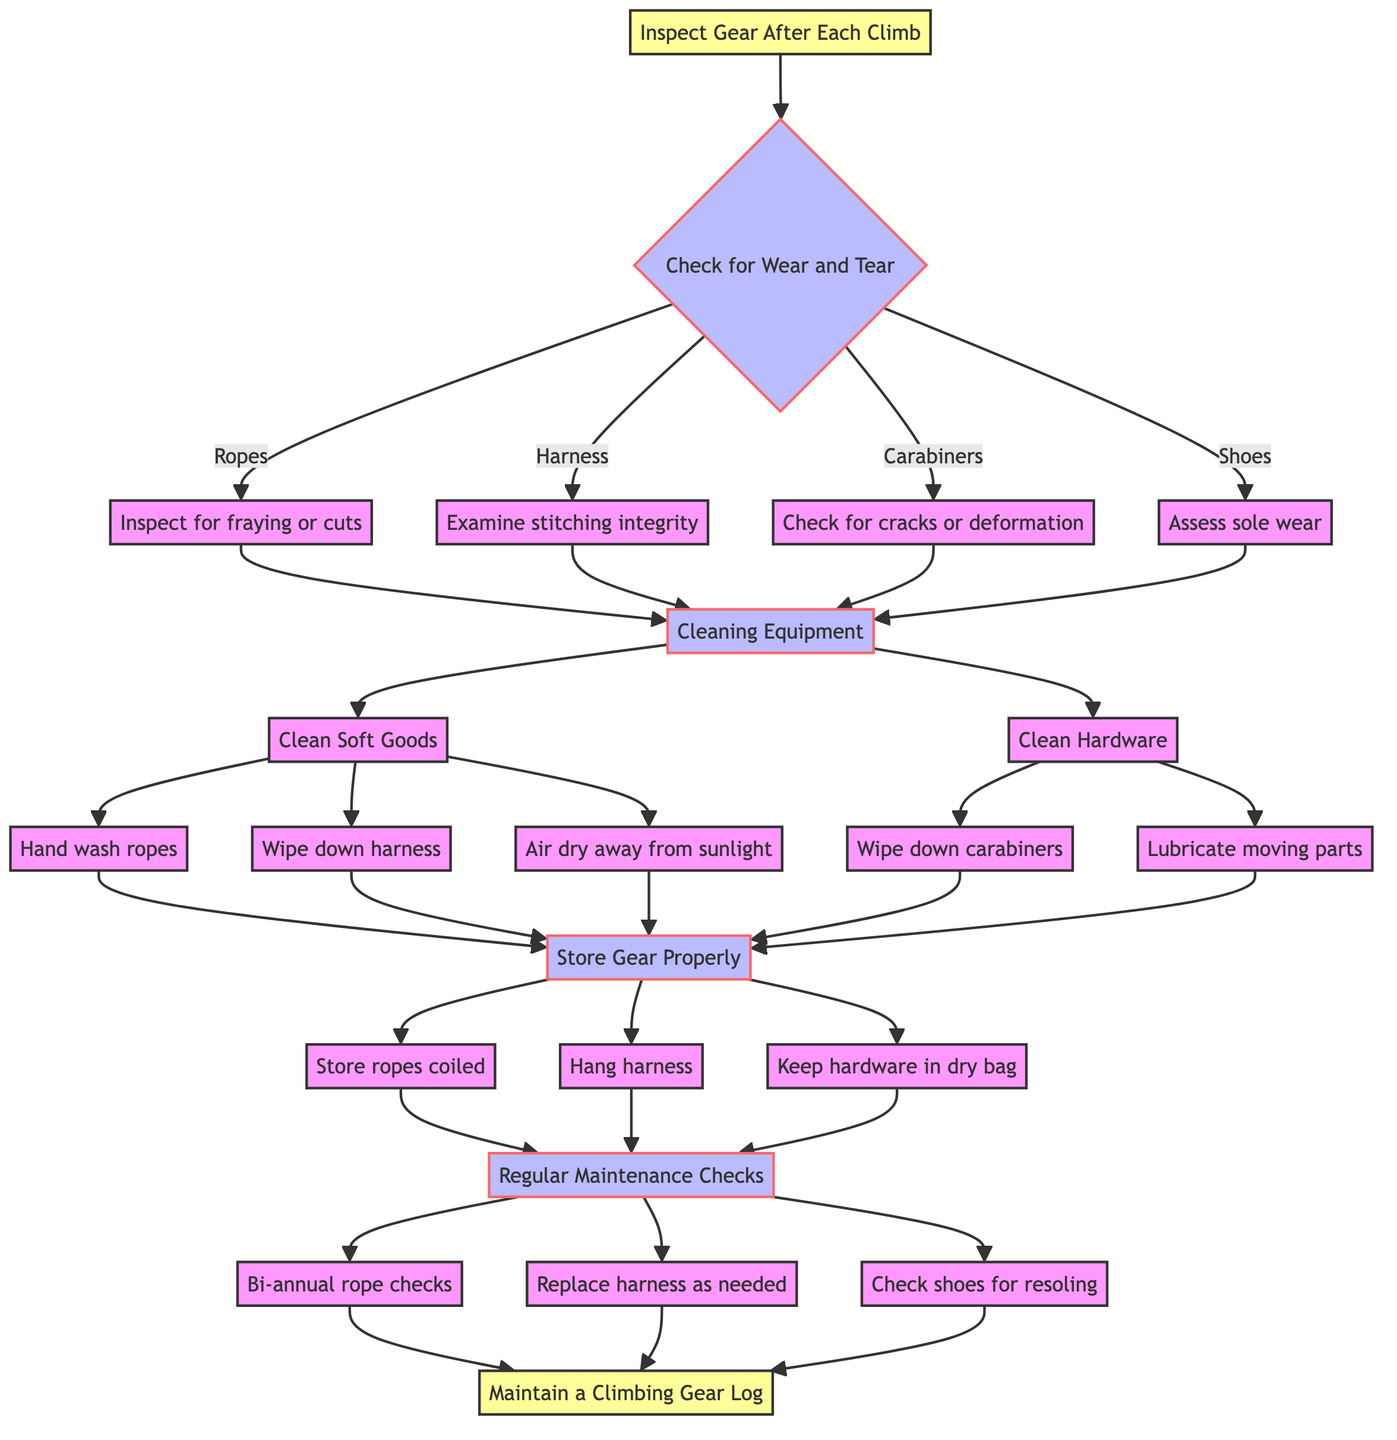What is the first step in the climbing gear maintenance routine? The first step in the diagram is represented by the node "Inspect Gear After Each Climb," which is where the maintenance process begins.
Answer: Inspect Gear After Each Climb How many substeps are there under the "Check for Wear and Tear" step? The diagram shows four substeps under "Check for Wear and Tear," which include inspecting ropes, examining the harness, checking carabiners, and assessing climbing shoes.
Answer: Four What do you do to clean soft goods? According to the diagram, cleaning soft goods involves three actions: hand washing ropes, wiping down the harness, and air drying all soft goods away from direct sunlight.
Answer: Hand wash ropes, wipe down harness, air dry What should you do to the carabiners as part of the cleaning process? The diagram specifies that carabiners need to be wiped down with a soft cloth and should be lubricated on their moving parts with light machine oil.
Answer: Wipe down and lubricate What do you keep in a dry gear bag? The "Store Gear Properly" step indicates that carabiners and other hardware are stored in a dry gear bag, emphasizing the need to keep equipment dry.
Answer: Carabiners and other hardware When should you schedule maintenance checks for rope integrity? The diagram specifies that regular maintenance checks for rope integrity should be scheduled bi-annually using a rope tester.
Answer: Bi-annual checks What action is taken if the harness reaches the maximum recommended usage years? The diagram clearly states that the action to take is to replace the harness after it has reached its maximum recommended usage years.
Answer: Replace harness Which step follows after cleaning the climbing gear? After the cleaning step, the next step outlined in the diagram is "Store Gear Properly," indicating that storing the gear is the subsequent task.
Answer: Store Gear Properly What is the final outcome of following the climbing gear maintenance routine? At the end of the flow chart, the final outcome is maintaining a climbing gear log, which summarizes the entire maintenance activity.
Answer: Maintain a Climbing Gear Log 